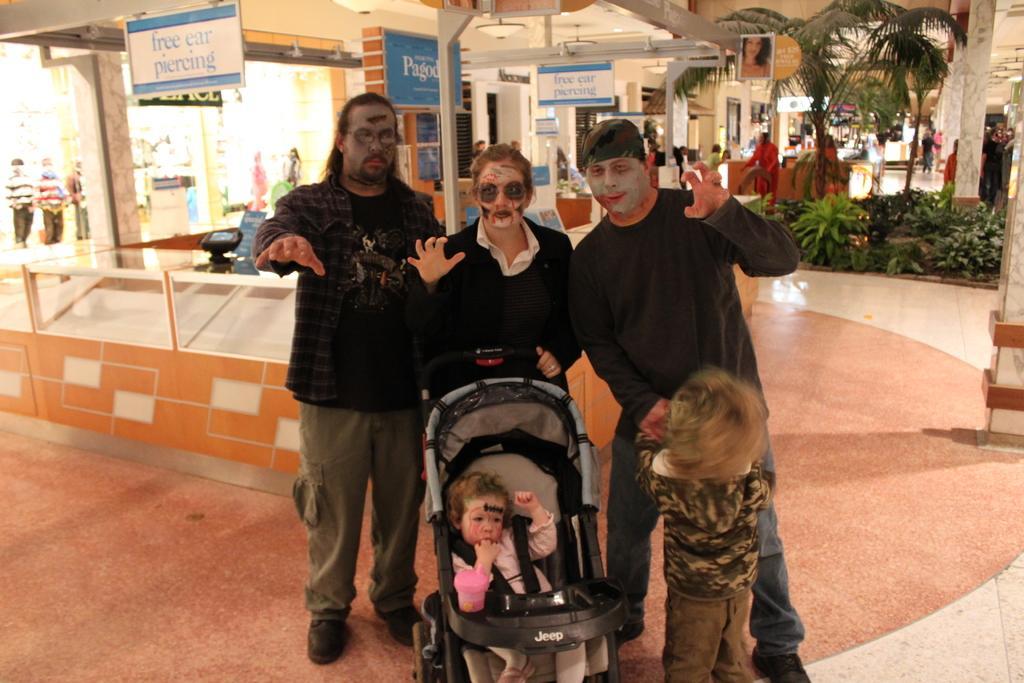In one or two sentences, can you explain what this image depicts? In this picture, there are people wearing Halloween makeup. All the people in the center are wearing black. The woman in the center is holding a baby vehicle. In the vehicle, there is a kid. Beside him there is another kid. In the background, there are stores and boards. Towards the right, there are people and plants. 